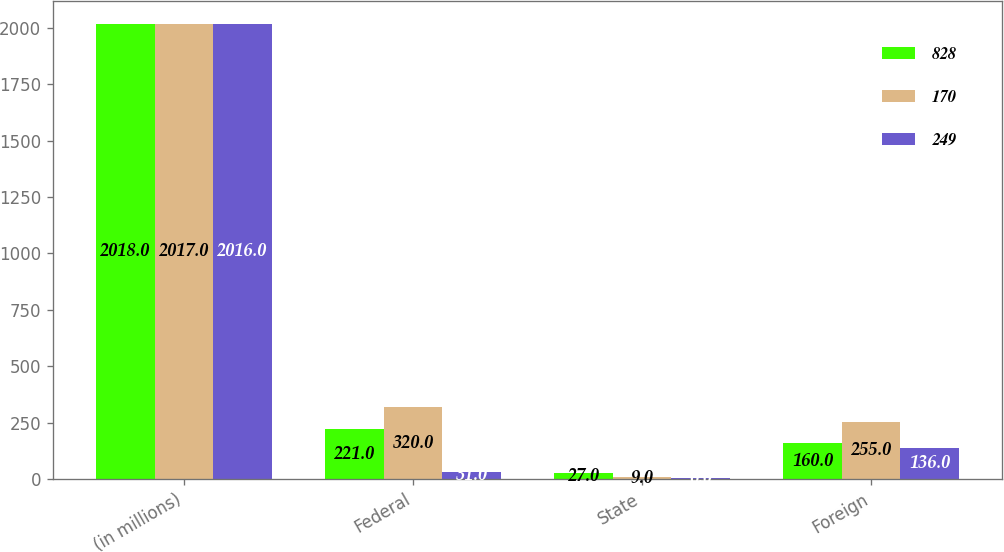<chart> <loc_0><loc_0><loc_500><loc_500><stacked_bar_chart><ecel><fcel>(in millions)<fcel>Federal<fcel>State<fcel>Foreign<nl><fcel>828<fcel>2018<fcel>221<fcel>27<fcel>160<nl><fcel>170<fcel>2017<fcel>320<fcel>9<fcel>255<nl><fcel>249<fcel>2016<fcel>31<fcel>6<fcel>136<nl></chart> 